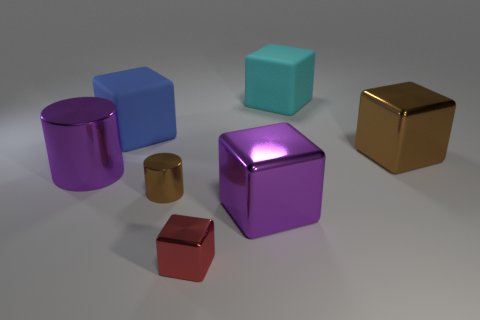Subtract all tiny red metallic blocks. How many blocks are left? 4 Add 1 big rubber objects. How many objects exist? 8 Subtract all purple cylinders. How many cylinders are left? 1 Subtract all blocks. How many objects are left? 2 Subtract 1 cylinders. How many cylinders are left? 1 Add 2 large blue matte objects. How many large blue matte objects are left? 3 Add 3 large cubes. How many large cubes exist? 7 Subtract 1 brown blocks. How many objects are left? 6 Subtract all purple cylinders. Subtract all purple cubes. How many cylinders are left? 1 Subtract all big purple cubes. Subtract all small cylinders. How many objects are left? 5 